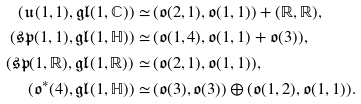Convert formula to latex. <formula><loc_0><loc_0><loc_500><loc_500>( { \mathfrak { u } } ( 1 , 1 ) , { \mathfrak { g l } } ( 1 , { \mathbb { C } } ) ) \simeq \, & ( { \mathfrak { o } } ( 2 , 1 ) , { \mathfrak { o } } ( 1 , 1 ) ) + ( { \mathbb { R } } , { \mathbb { R } } ) , \\ ( { \mathfrak { s p } } ( 1 , 1 ) , { \mathfrak { g l } } ( 1 , { \mathbb { H } } ) ) \simeq \, & ( { \mathfrak { o } } ( 1 , 4 ) , { \mathfrak { o } } ( 1 , 1 ) + { \mathfrak { o } } ( 3 ) ) , \\ ( { \mathfrak { s p } } ( 1 , { \mathbb { R } } ) , { \mathfrak { g l } } ( 1 , { \mathbb { R } } ) ) \simeq \, & ( { \mathfrak { o } } ( 2 , 1 ) , { \mathfrak { o } } ( 1 , 1 ) ) , \\ ( { \mathfrak { o } } ^ { \ast } ( 4 ) , { \mathfrak { g l } } ( 1 , { \mathbb { H } } ) ) \simeq \, & ( { \mathfrak { o } } ( 3 ) , { \mathfrak { o } } ( 3 ) ) \oplus ( { \mathfrak { o } } ( 1 , 2 ) , { \mathfrak { o } } ( 1 , 1 ) ) .</formula> 